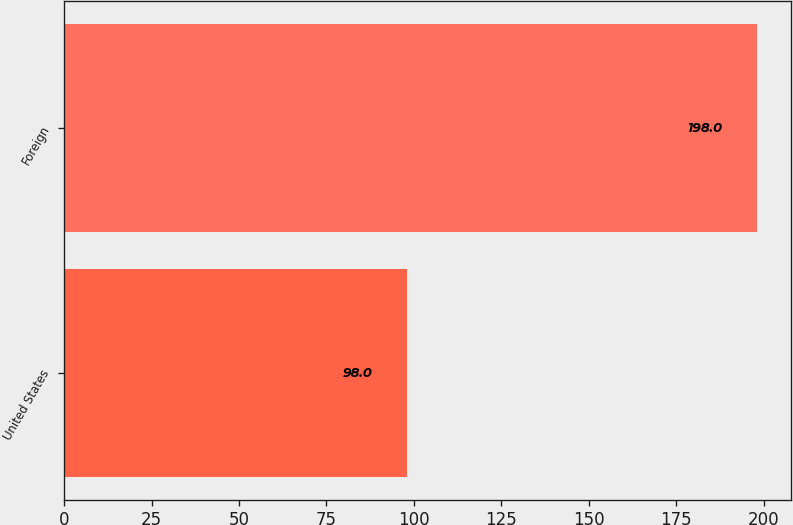Convert chart to OTSL. <chart><loc_0><loc_0><loc_500><loc_500><bar_chart><fcel>United States<fcel>Foreign<nl><fcel>98<fcel>198<nl></chart> 